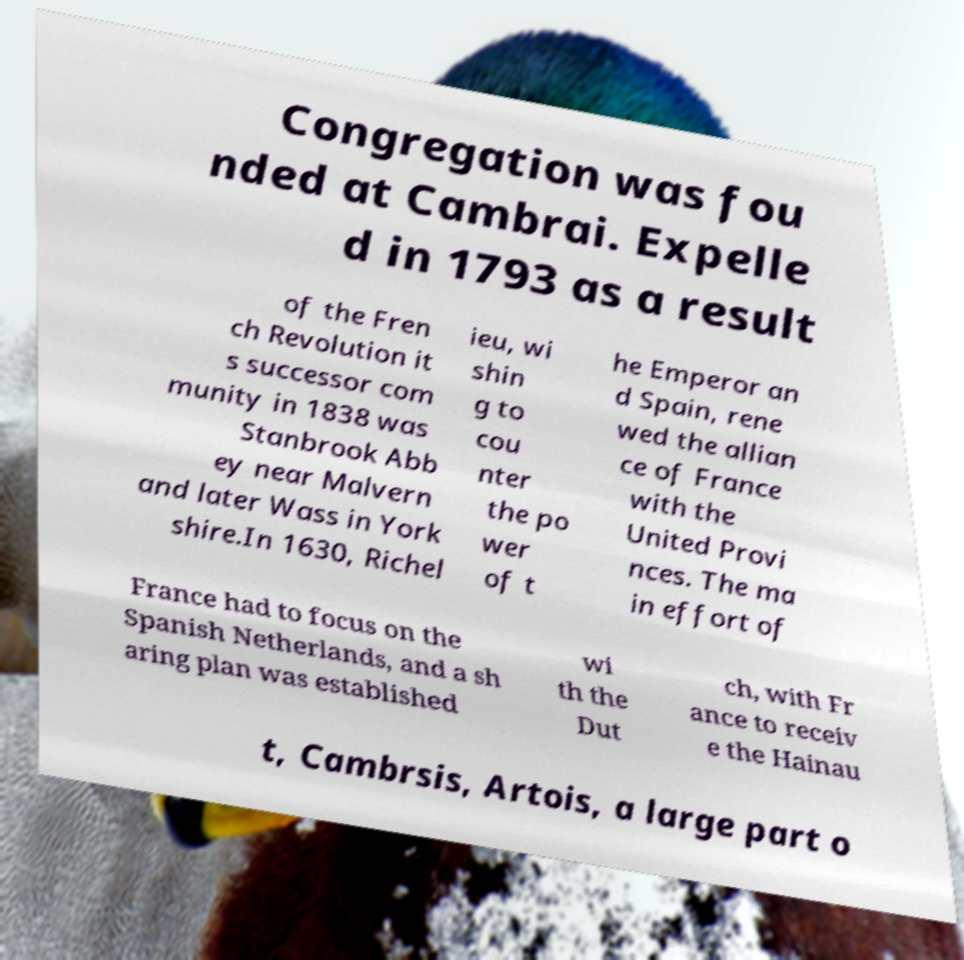Could you assist in decoding the text presented in this image and type it out clearly? Congregation was fou nded at Cambrai. Expelle d in 1793 as a result of the Fren ch Revolution it s successor com munity in 1838 was Stanbrook Abb ey near Malvern and later Wass in York shire.In 1630, Richel ieu, wi shin g to cou nter the po wer of t he Emperor an d Spain, rene wed the allian ce of France with the United Provi nces. The ma in effort of France had to focus on the Spanish Netherlands, and a sh aring plan was established wi th the Dut ch, with Fr ance to receiv e the Hainau t, Cambrsis, Artois, a large part o 